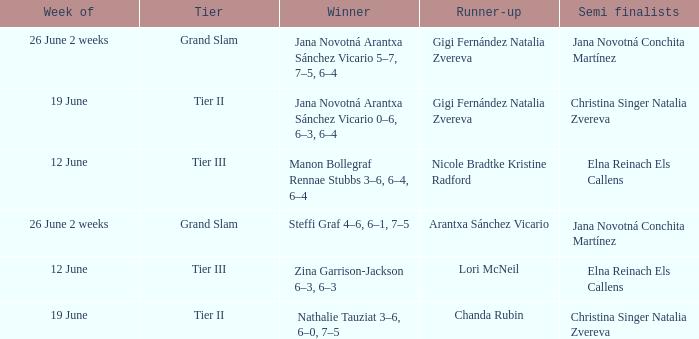In which week is the winner listed as Jana Novotná Arantxa Sánchez Vicario 5–7, 7–5, 6–4? 26 June 2 weeks. 